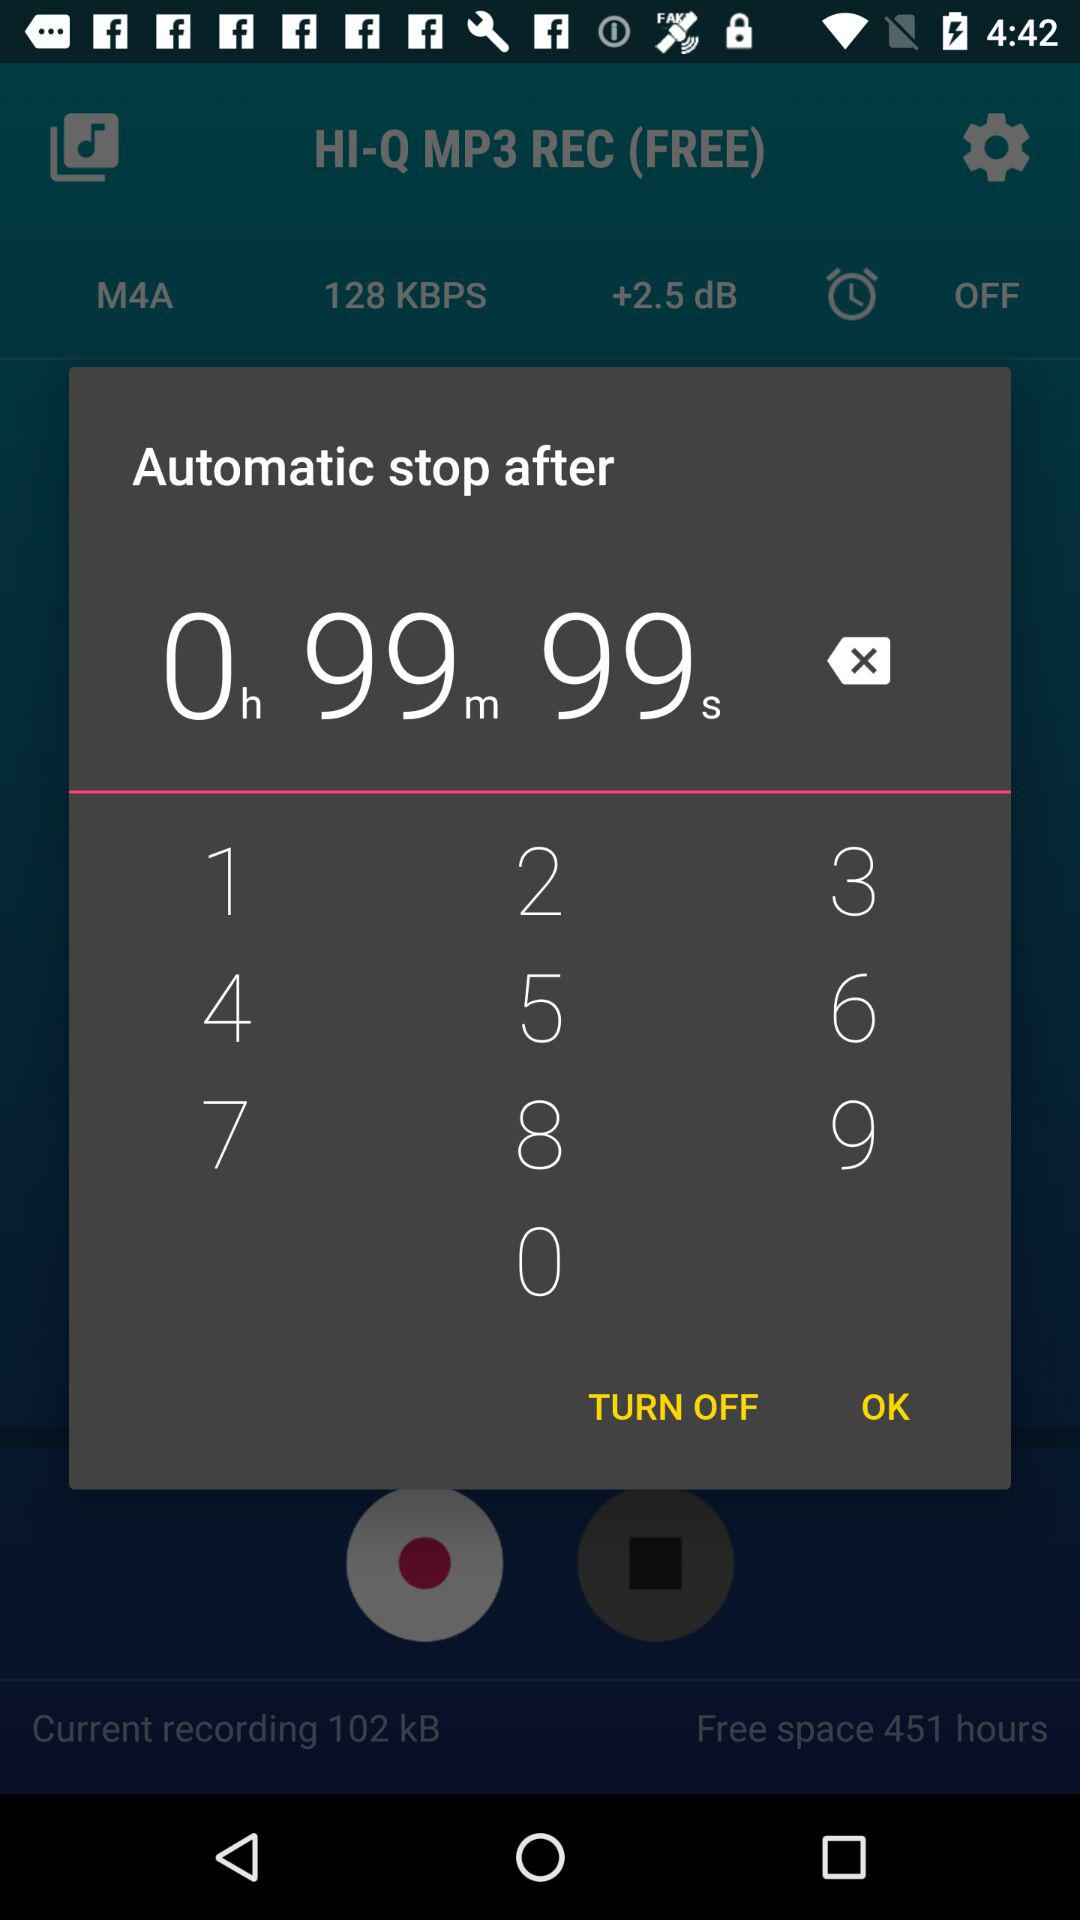Automatic stop time after how many minutes? The time is 99 minutes. 